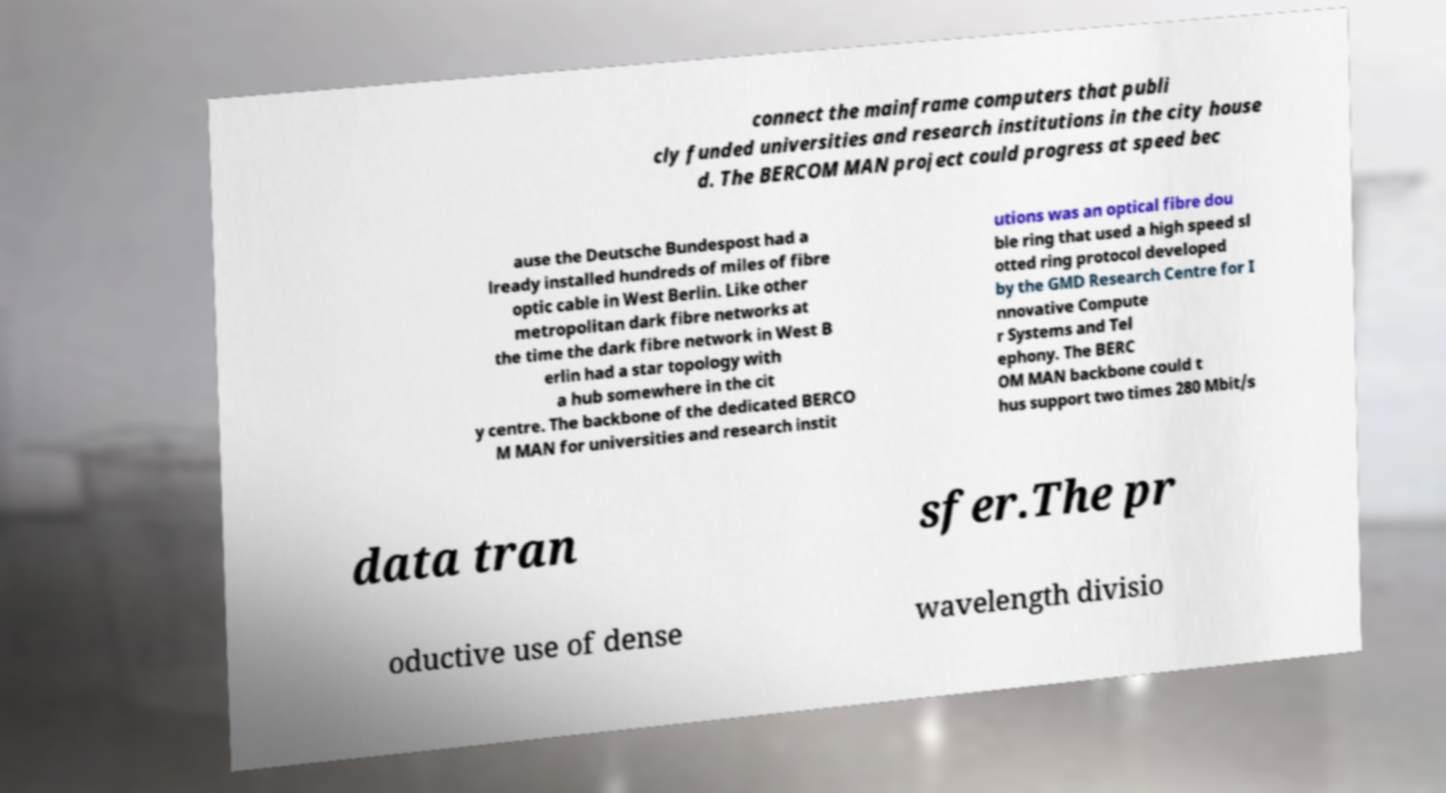Could you assist in decoding the text presented in this image and type it out clearly? connect the mainframe computers that publi cly funded universities and research institutions in the city house d. The BERCOM MAN project could progress at speed bec ause the Deutsche Bundespost had a lready installed hundreds of miles of fibre optic cable in West Berlin. Like other metropolitan dark fibre networks at the time the dark fibre network in West B erlin had a star topology with a hub somewhere in the cit y centre. The backbone of the dedicated BERCO M MAN for universities and research instit utions was an optical fibre dou ble ring that used a high speed sl otted ring protocol developed by the GMD Research Centre for I nnovative Compute r Systems and Tel ephony. The BERC OM MAN backbone could t hus support two times 280 Mbit/s data tran sfer.The pr oductive use of dense wavelength divisio 